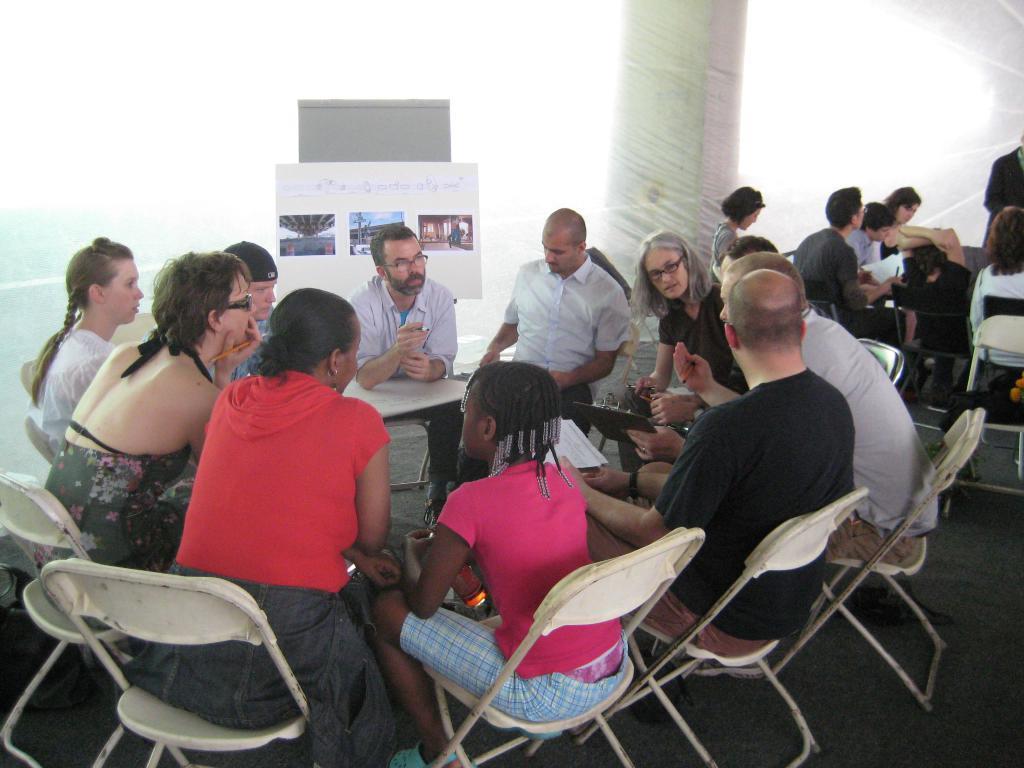Could you give a brief overview of what you see in this image? In this picture we can see a group of people sitting on chair and discussing and the background we can see pillar, board some poster is attached to it. 